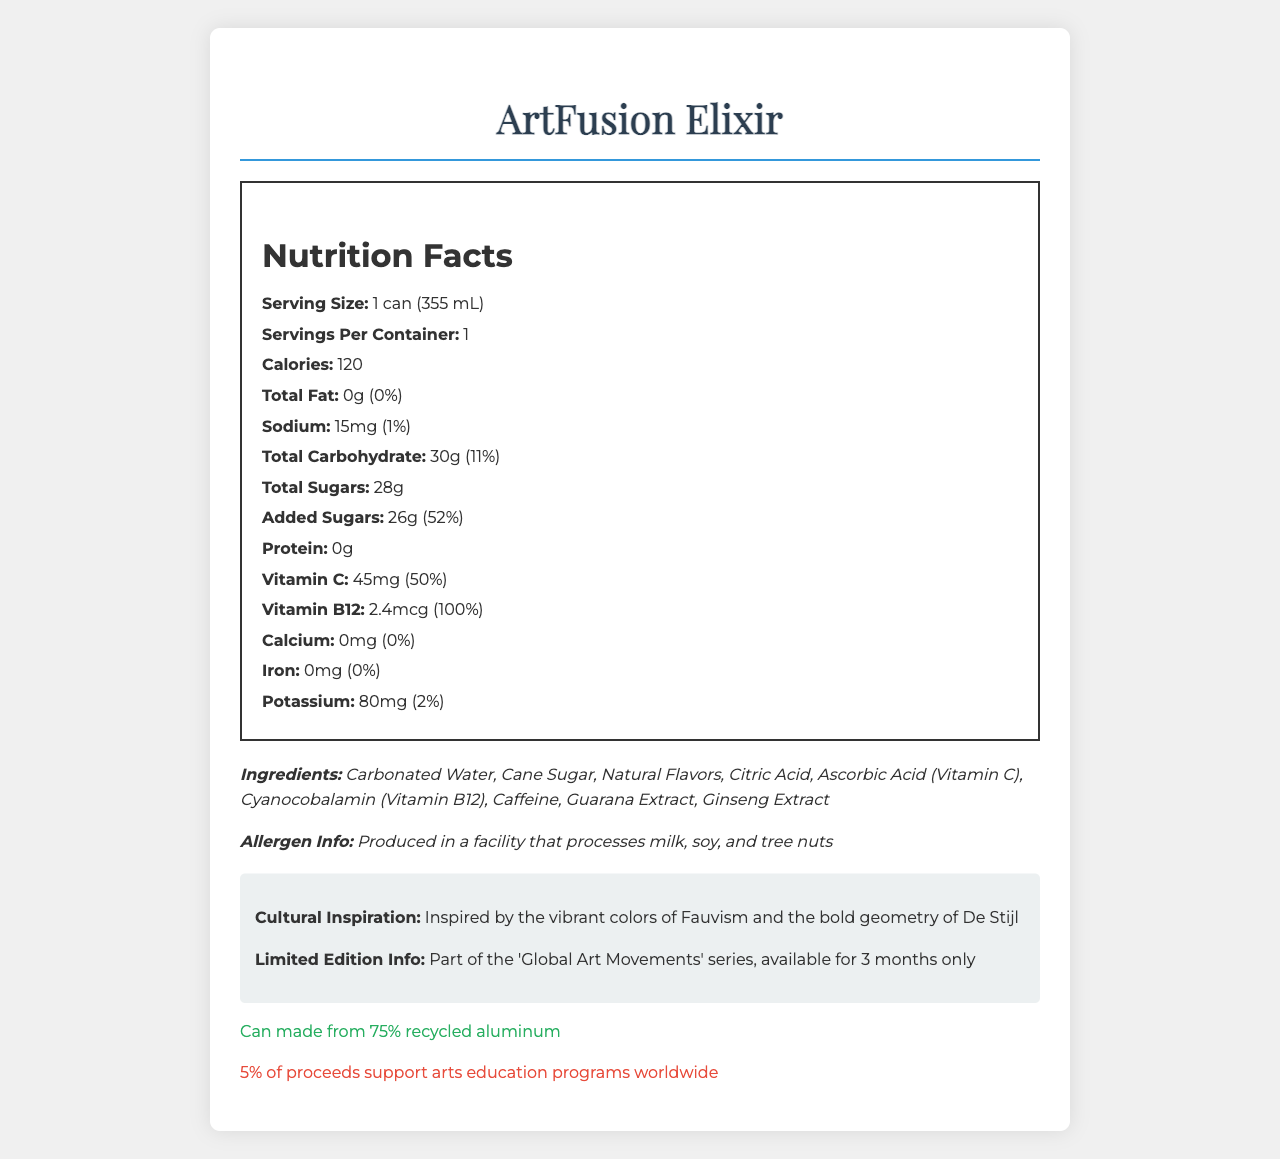what is the product name? The product name is displayed at the top of the document within the page's title and header.
Answer: ArtFusion Elixir what is the serving size of the beverage? The serving size is shown under the "Nutrition Facts" section.
Answer: 1 can (355 mL) how many calories are in one serving of ArtFusion Elixir? The calorie content is listed under the "Nutrition Facts" with the label "Calories."
Answer: 120 how much total carbohydrate is in a serving? The amount of total carbohydrate is mentioned in the "Nutrition Facts" section.
Answer: 30g what ingredients are contained in ArtFusion Elixir? The ingredients are listed at the bottom of the document.
Answer: Carbonated Water, Cane Sugar, Natural Flavors, Citric Acid, Ascorbic Acid (Vitamin C), Cyanocobalamin (Vitamin B12), Caffeine, Guarana Extract, Ginseng Extract what is the percentage of the daily value of Vitamin B12 in a serving? A. 50% B. 75% C. 100% D. 25% The daily value percentage for Vitamin B12 is shown in the "Nutrition Facts" section.
Answer: C. 100% what is the charitable contribution from the purchase of ArtFusion Elixir? A. 1% B. 2% C. 3% D. 5% The charitable contribution percentage is mentioned under the "charity" section.
Answer: D. 5% is ArtFusion Elixir part of a limited-edition series? The document states that it is "Part of the 'Global Art Movements' series, available for 3 months only."
Answer: Yes does ArtFusion Elixir contain any proteins? The "Nutrition Facts" section shows that the protein content is 0g.
Answer: No what is the cultural inspiration behind ArtFusion Elixir? The cultural inspiration is detailed in the "cultural-info" section of the document.
Answer: Inspired by the vibrant colors of Fauvism and the bold geometry of De Stijl summarize the main features of ArtFusion Elixir based on the document. This summary includes the key details from the "Nutrition Facts," ingredients, cultural inspiration, sustainability note, and charitable contribution sections.
Answer: ArtFusion Elixir is a limited-edition beverage inspired by global art movements, specifically the vibrant colors of Fauvism and the bold geometry of De Stijl. It contains 120 calories per can, with significant levels of Vitamin C and Vitamin B12 but zero fats and proteins. Ingredients include carbonated water, cane sugar, natural flavors, and various extracts. The product is part of a series available for 3 months, is packed in a can made from 75% recycled aluminum, and supports arts education programs with 5% of the proceeds. what is the total fat content in a serving of ArtFusion Elixir? The total fat content is listed as 0g in the "Nutrition Facts" section.
Answer: 0g what percentage of the daily value for added sugars does a serving contain? The daily value percentage for added sugars is mentioned under the "Total Sugars" section.
Answer: 52% how much potassium is in a serving of ArtFusion Elixir? The potassium content is listed as 80mg in the "Nutrition Facts" section.
Answer: 80mg alongside which other products is ArtFusion Elixir produced in terms of potential allergens? The allergen information states that it is produced in a facility that processes milk, soy, and tree nuts.
Answer: Milk, soy, and tree nuts what is the caffeine content in ArtFusion Elixir? The document lists caffeine among the ingredients but does not provide a specific amount for caffeine content.
Answer: Cannot be determined 